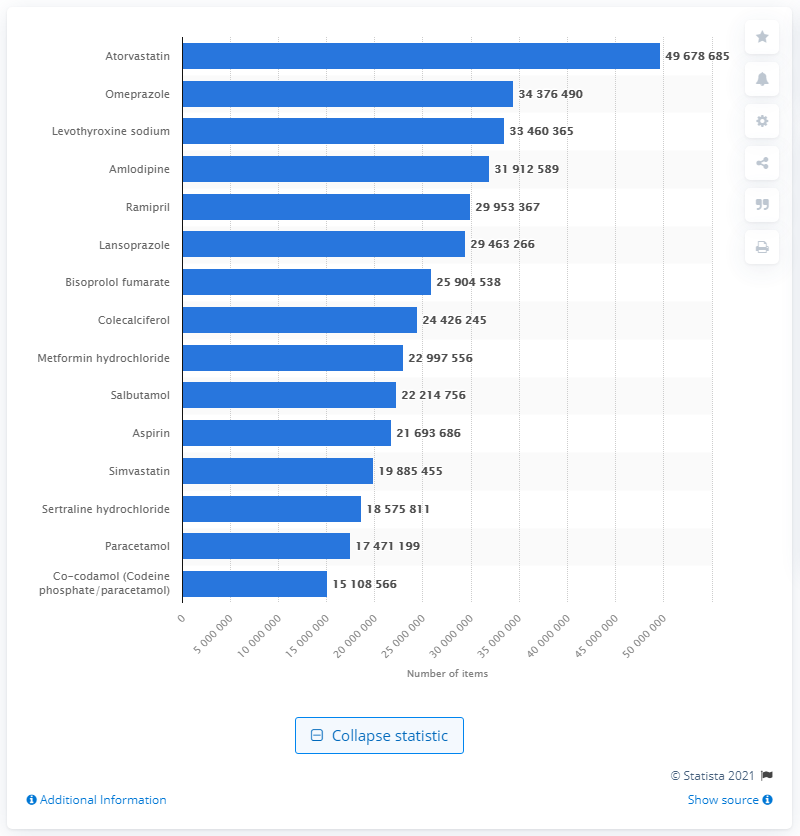Indicate a few pertinent items in this graphic. In 2020, the most dispensed chemical drug in England was Atorvastatin. 